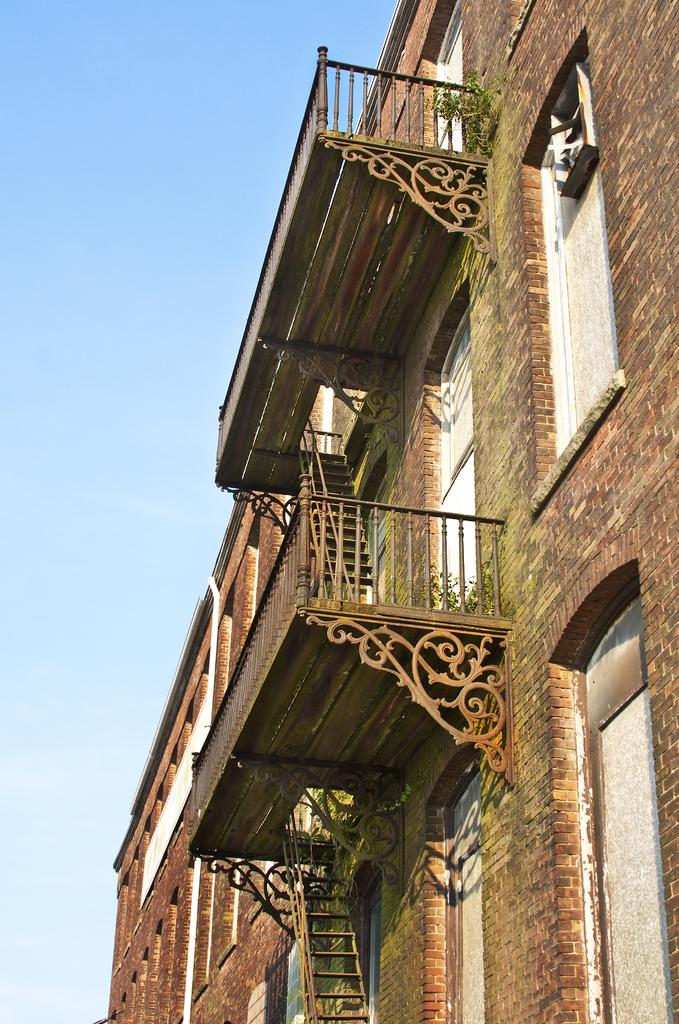What type of structure is present in the image? There is a building in the image. What material is used for the walls of the building? The building has brick walls. What features can be seen on the building? The building contains windows, doors, staircases, and railings. What can be seen in the background of the image? The sky is visible in the background of the image. What color is the queen's sweater in the image? There is no queen or sweater present in the image; it features a building with various architectural features. 